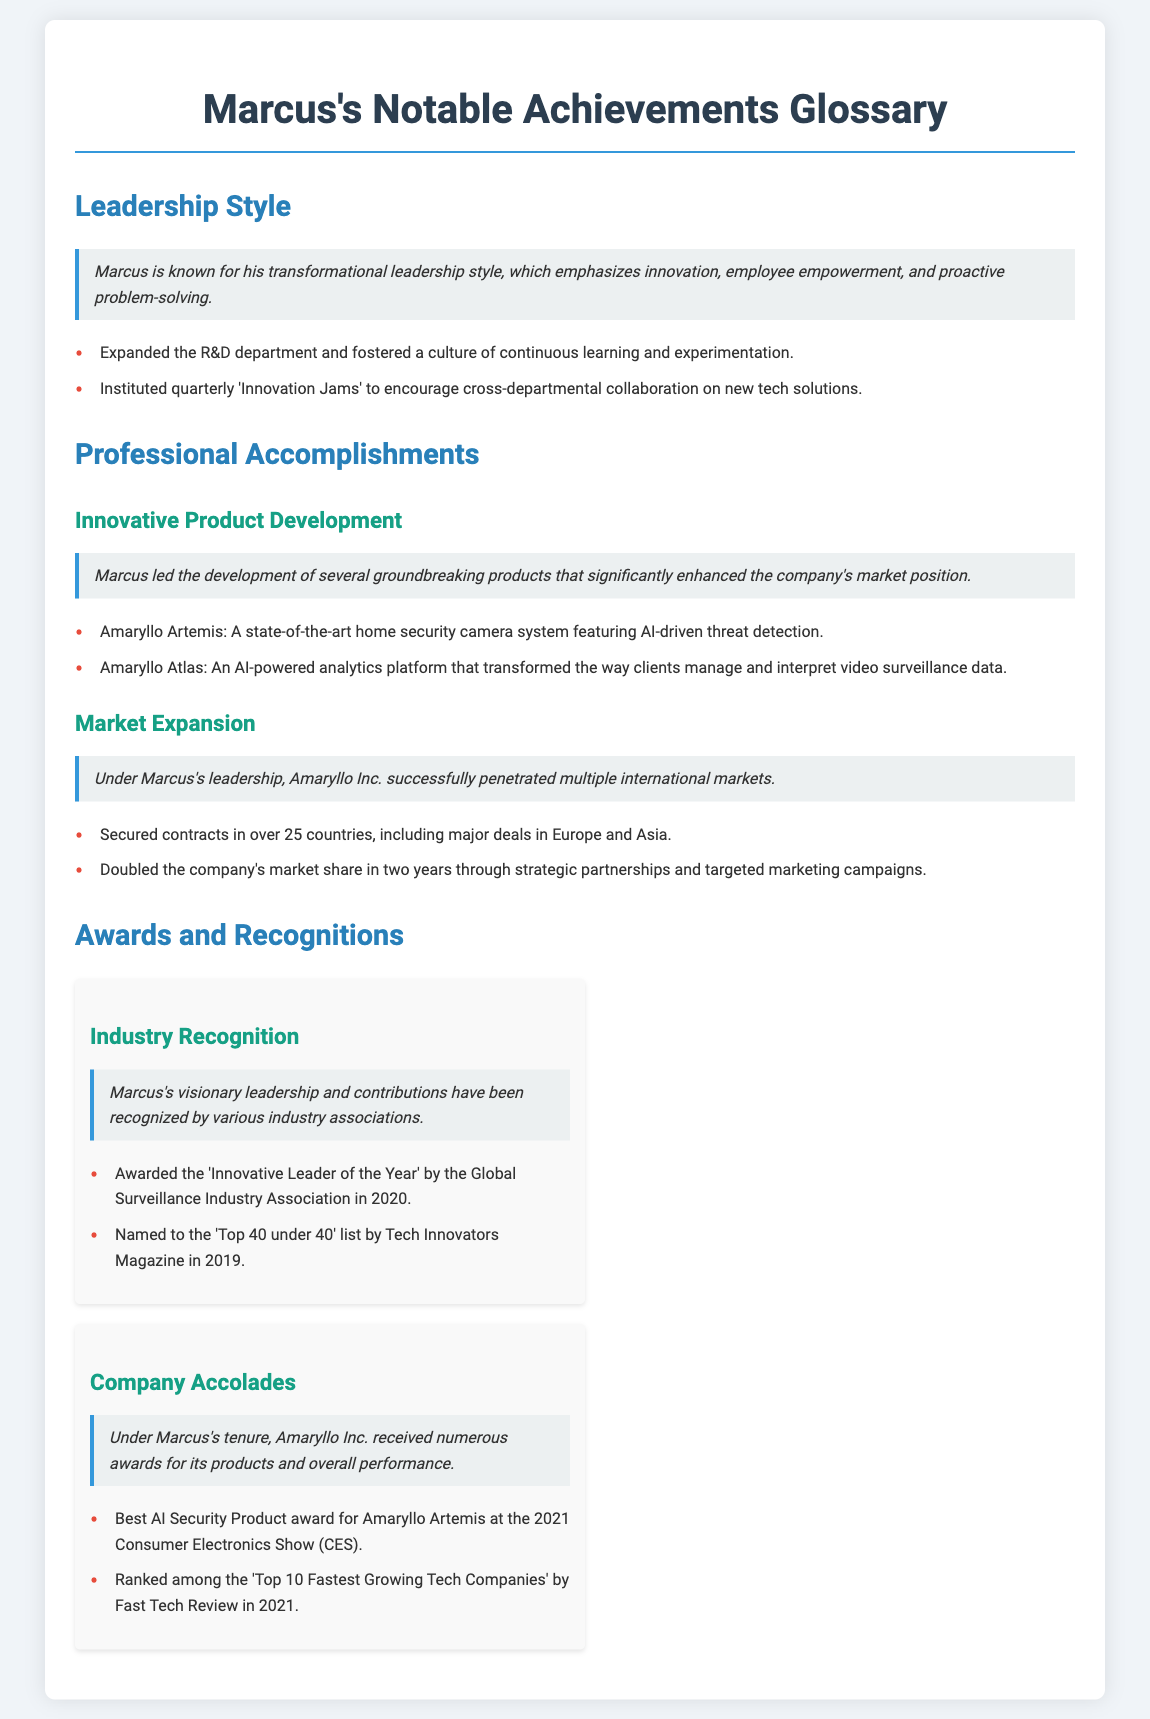What leadership style is Marcus known for? The document states that Marcus is known for his transformational leadership style.
Answer: transformational leadership What product is associated with AI-driven threat detection? The Amaryllo Artemis is mentioned as a home security camera system featuring AI-driven threat detection.
Answer: Amaryllo Artemis In which year did Marcus receive the 'Innovative Leader of the Year' award? The document specifies that Marcus was awarded the 'Innovative Leader of the Year' in 2020.
Answer: 2020 How many countries did Amaryllo secure contracts in under Marcus's leadership? It is noted that Amaryllo secured contracts in over 25 countries during this time.
Answer: over 25 countries What award did Amaryllo Artemis win at CES in 2021? The document highlights that Amaryllo Artemis received the Best AI Security Product award at CES 2021.
Answer: Best AI Security Product Who named Marcus to the 'Top 40 under 40' list? The document mentions that Tech Innovators Magazine named Marcus to this list.
Answer: Tech Innovators Magazine What unique event did Marcus institute to encourage collaboration? The document refers to quarterly 'Innovation Jams' as an event instituted by Marcus to encourage collaboration.
Answer: quarterly 'Innovation Jams' Which region saw major contracts secured under Marcus's leadership? The document indicates that major deals were secured in Europe and Asia.
Answer: Europe and Asia 